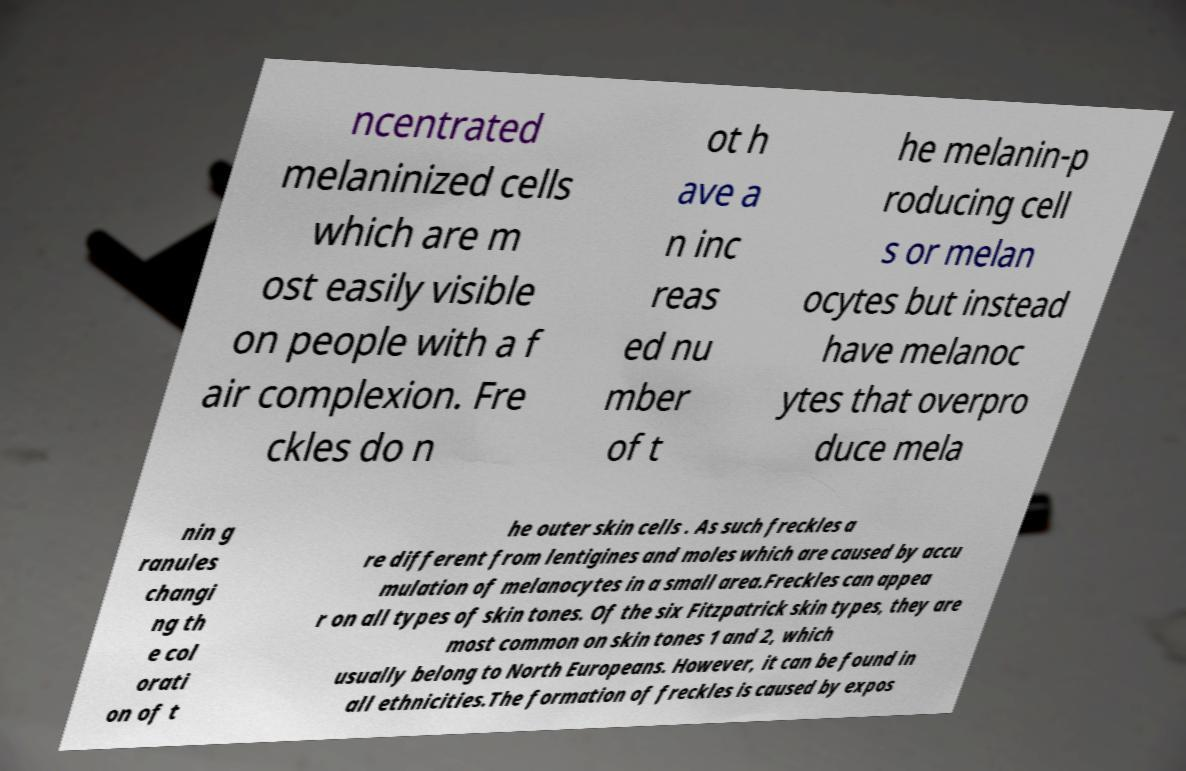Can you accurately transcribe the text from the provided image for me? ncentrated melaninized cells which are m ost easily visible on people with a f air complexion. Fre ckles do n ot h ave a n inc reas ed nu mber of t he melanin-p roducing cell s or melan ocytes but instead have melanoc ytes that overpro duce mela nin g ranules changi ng th e col orati on of t he outer skin cells . As such freckles a re different from lentigines and moles which are caused by accu mulation of melanocytes in a small area.Freckles can appea r on all types of skin tones. Of the six Fitzpatrick skin types, they are most common on skin tones 1 and 2, which usually belong to North Europeans. However, it can be found in all ethnicities.The formation of freckles is caused by expos 